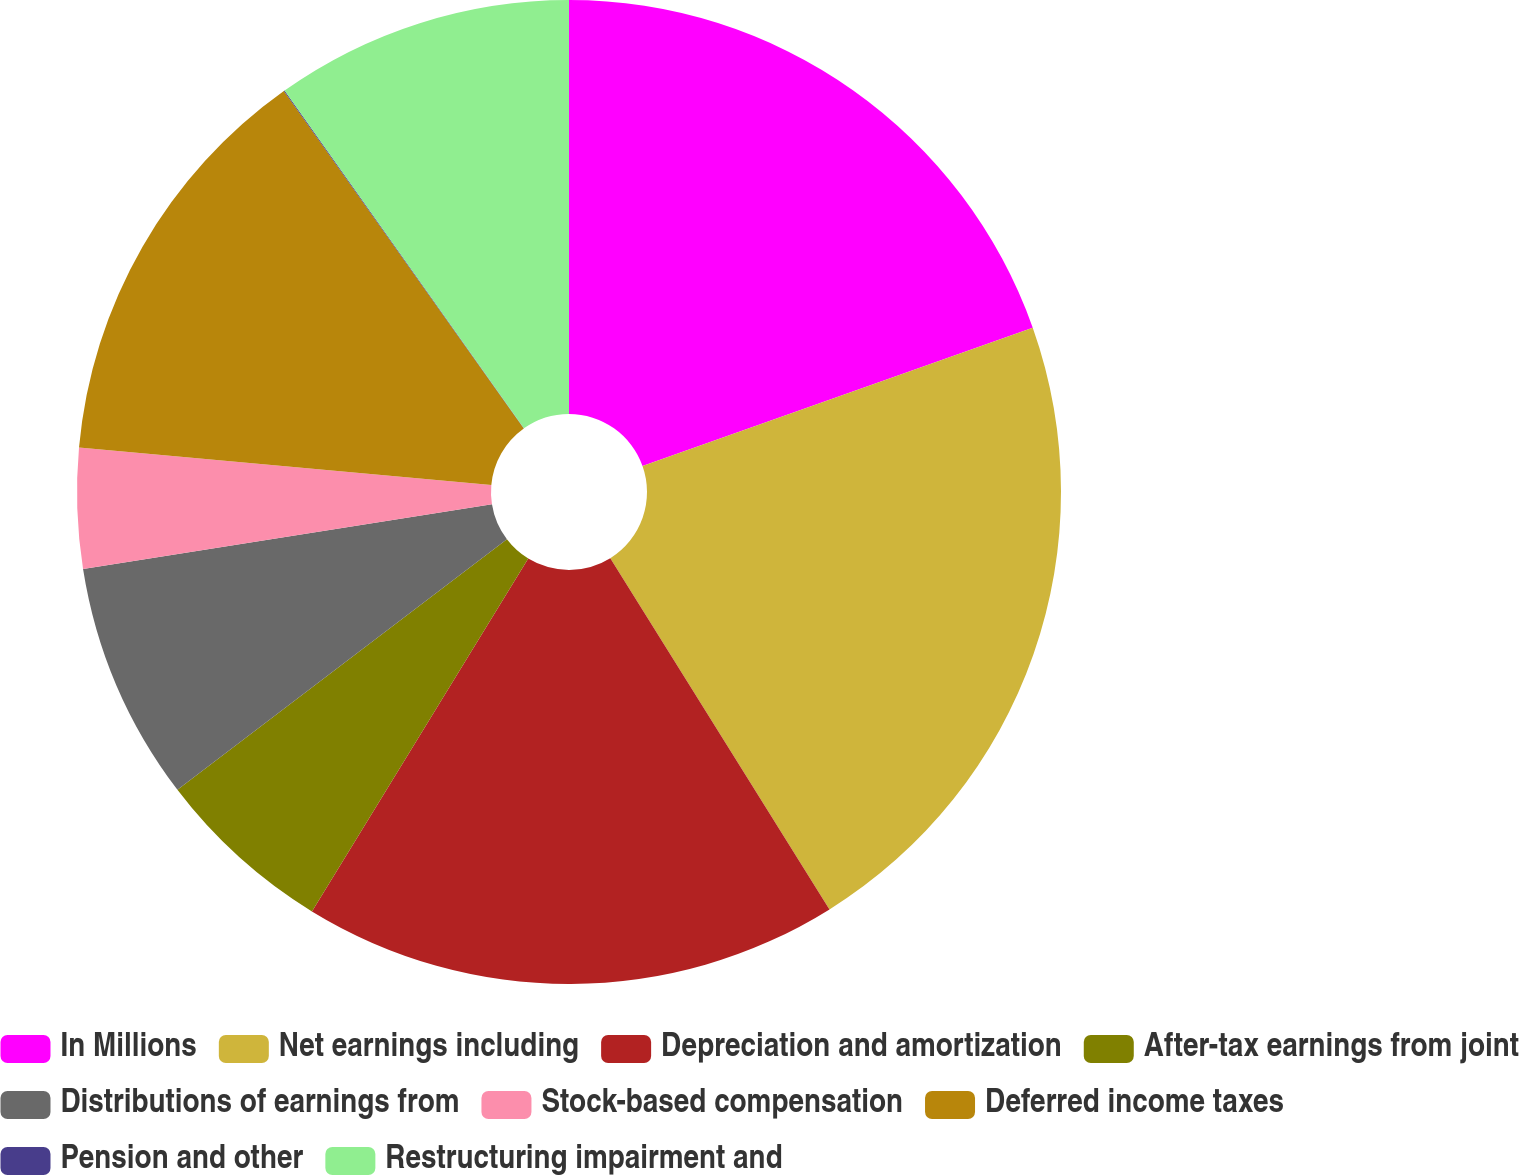Convert chart. <chart><loc_0><loc_0><loc_500><loc_500><pie_chart><fcel>In Millions<fcel>Net earnings including<fcel>Depreciation and amortization<fcel>After-tax earnings from joint<fcel>Distributions of earnings from<fcel>Stock-based compensation<fcel>Deferred income taxes<fcel>Pension and other<fcel>Restructuring impairment and<nl><fcel>19.58%<fcel>21.54%<fcel>17.63%<fcel>5.9%<fcel>7.85%<fcel>3.94%<fcel>13.72%<fcel>0.03%<fcel>9.81%<nl></chart> 